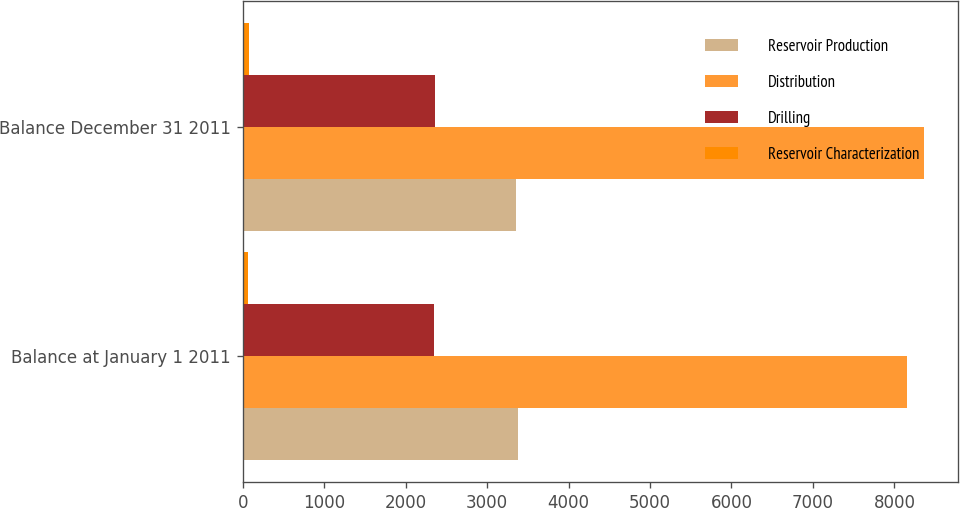Convert chart. <chart><loc_0><loc_0><loc_500><loc_500><stacked_bar_chart><ecel><fcel>Balance at January 1 2011<fcel>Balance December 31 2011<nl><fcel>Reservoir Production<fcel>3381<fcel>3360<nl><fcel>Distribution<fcel>8150<fcel>8362<nl><fcel>Drilling<fcel>2351<fcel>2356<nl><fcel>Reservoir Characterization<fcel>70<fcel>76<nl></chart> 